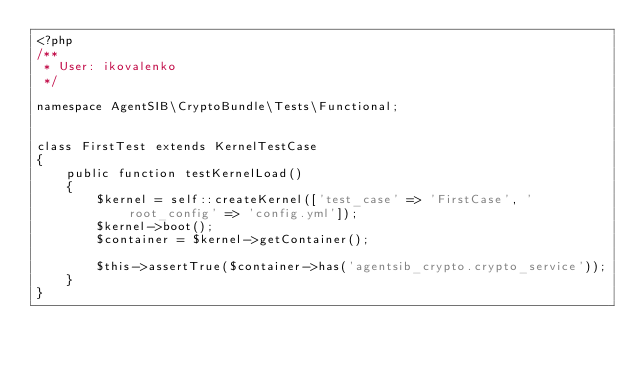<code> <loc_0><loc_0><loc_500><loc_500><_PHP_><?php
/**
 * User: ikovalenko
 */

namespace AgentSIB\CryptoBundle\Tests\Functional;


class FirstTest extends KernelTestCase
{
    public function testKernelLoad()
    {
        $kernel = self::createKernel(['test_case' => 'FirstCase', 'root_config' => 'config.yml']);
        $kernel->boot();
        $container = $kernel->getContainer();

        $this->assertTrue($container->has('agentsib_crypto.crypto_service'));
    }
}</code> 